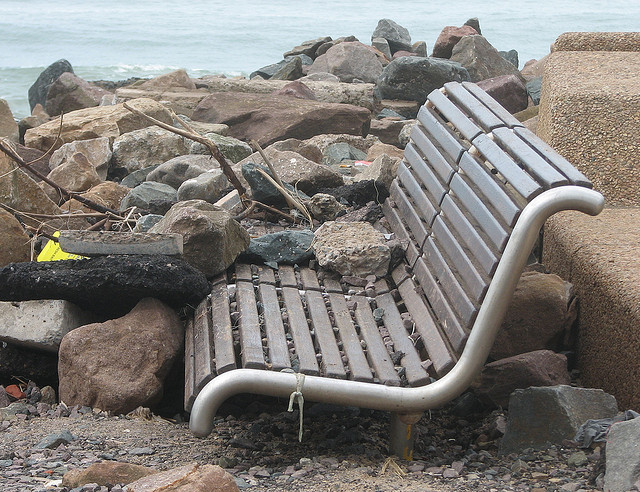What is the condition of the bench in the picture? The bench in the image looks worn and slightly damaged, indicating it has been exposed to the elements for a significant period. 